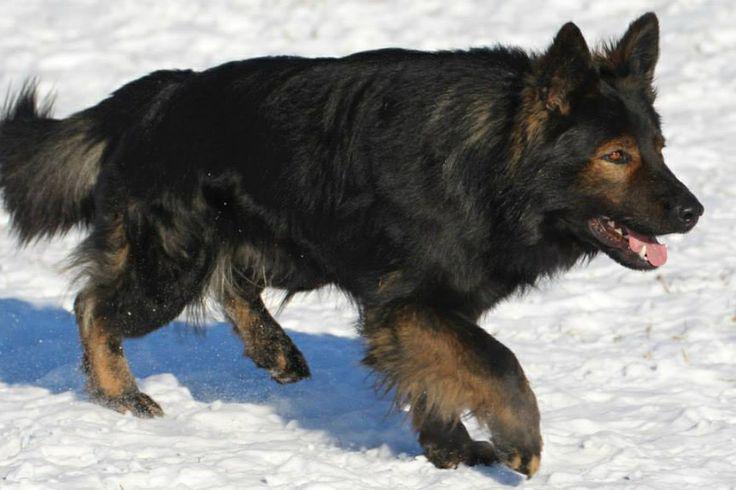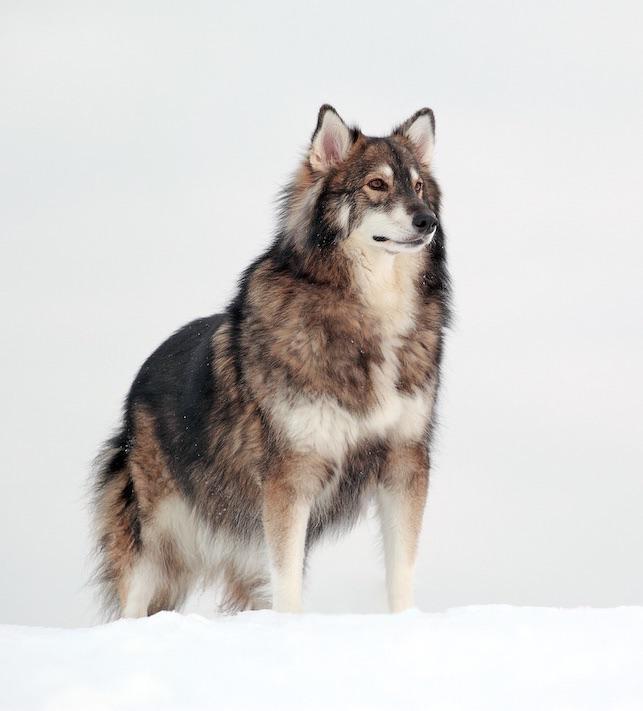The first image is the image on the left, the second image is the image on the right. For the images shown, is this caption "The left and right image contains the same number of dogs pointed in opposite directions." true? Answer yes or no. No. The first image is the image on the left, the second image is the image on the right. Examine the images to the left and right. Is the description "Two dogs are in snow." accurate? Answer yes or no. Yes. 